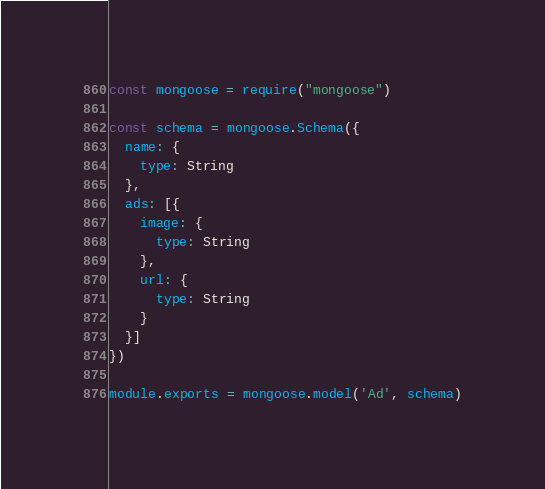<code> <loc_0><loc_0><loc_500><loc_500><_JavaScript_>const mongoose = require("mongoose")

const schema = mongoose.Schema({
  name: {
    type: String
  },
  ads: [{
    image: {
      type: String
    },
    url: {
      type: String
    }
  }]
})

module.exports = mongoose.model('Ad', schema)</code> 